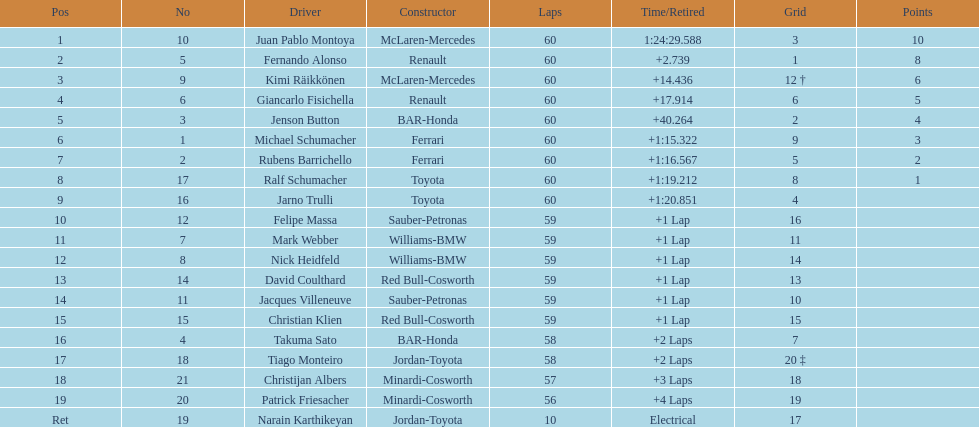Which driver has his grid at 2? Jenson Button. 